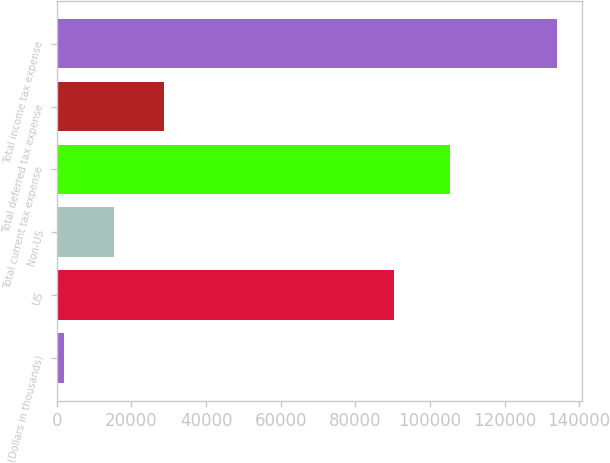Convert chart to OTSL. <chart><loc_0><loc_0><loc_500><loc_500><bar_chart><fcel>(Dollars in thousands)<fcel>US<fcel>Non-US<fcel>Total current tax expense<fcel>Total deferred tax expense<fcel>Total income tax expense<nl><fcel>2015<fcel>90486<fcel>15215.6<fcel>105297<fcel>28724<fcel>134021<nl></chart> 